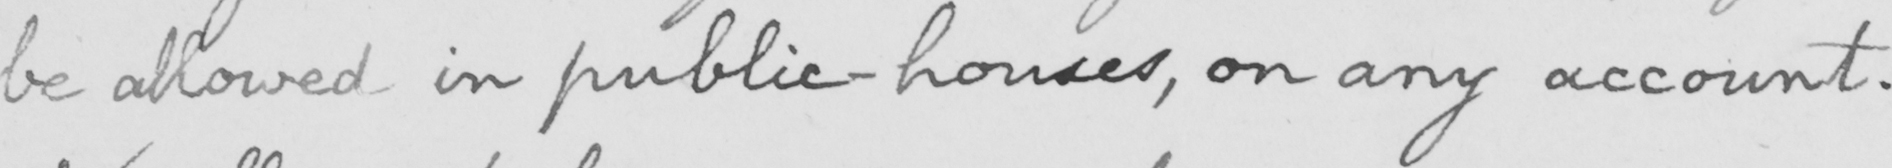Can you tell me what this handwritten text says? be allowed in public-houses , on any account . 